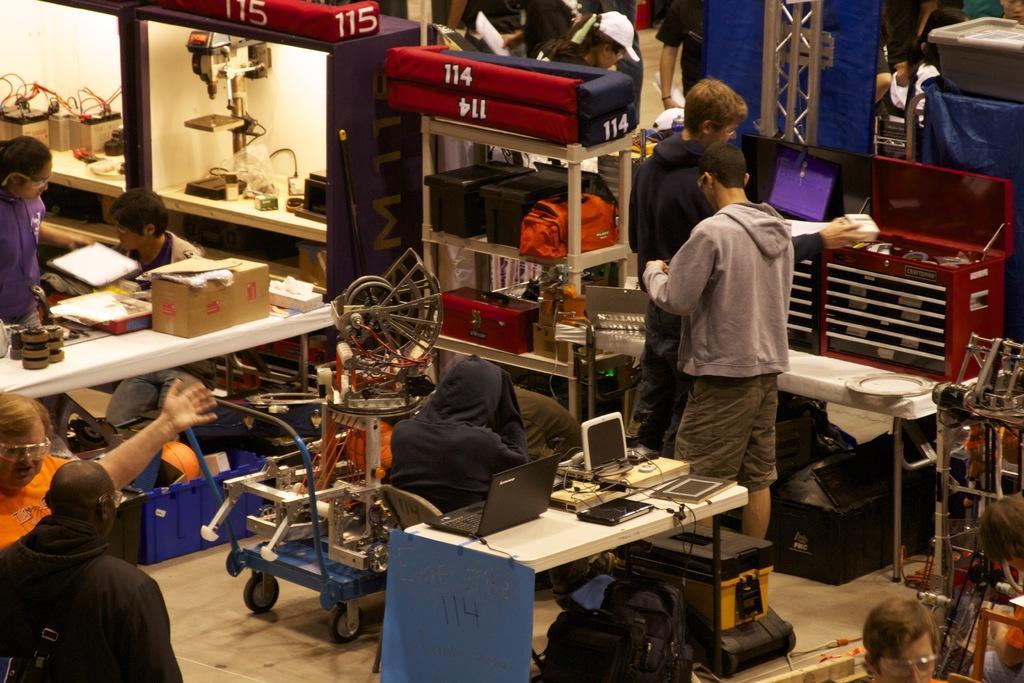Can you describe this image briefly? In this image, we can see persons wearing clothes. There are racks contains boxes and some electrical equipment. There is a machine in the middle of the image. There are tables contains laptop, boxes and some electrical equipment. 